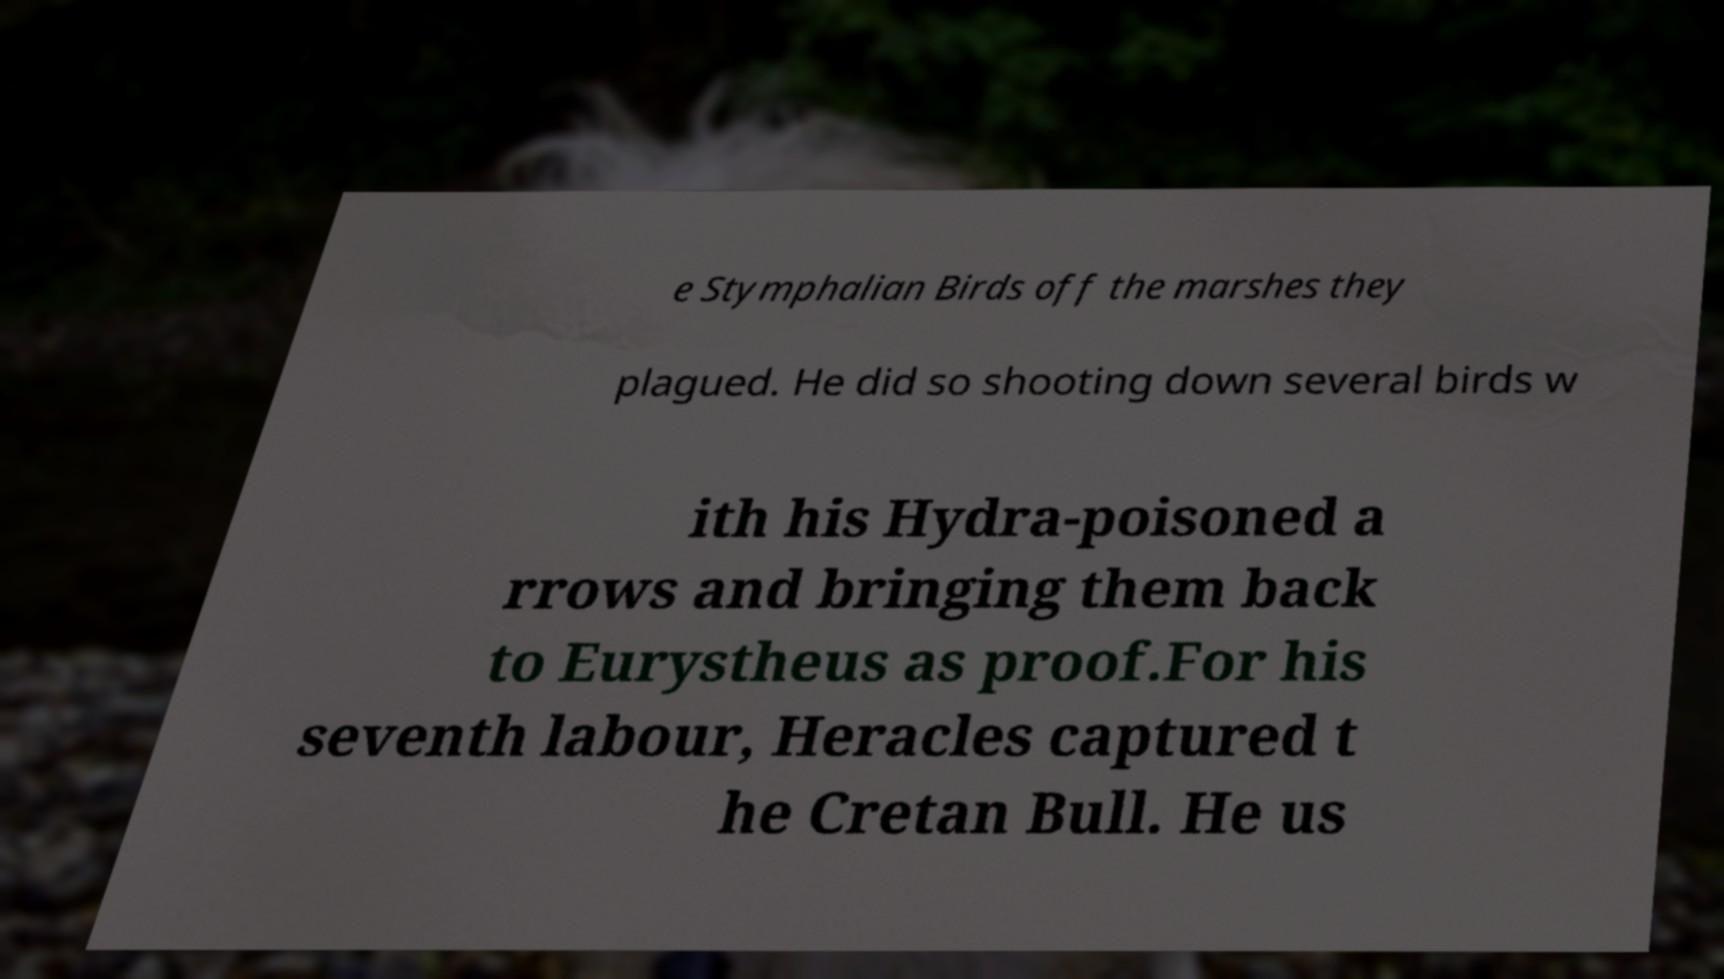Can you accurately transcribe the text from the provided image for me? e Stymphalian Birds off the marshes they plagued. He did so shooting down several birds w ith his Hydra-poisoned a rrows and bringing them back to Eurystheus as proof.For his seventh labour, Heracles captured t he Cretan Bull. He us 